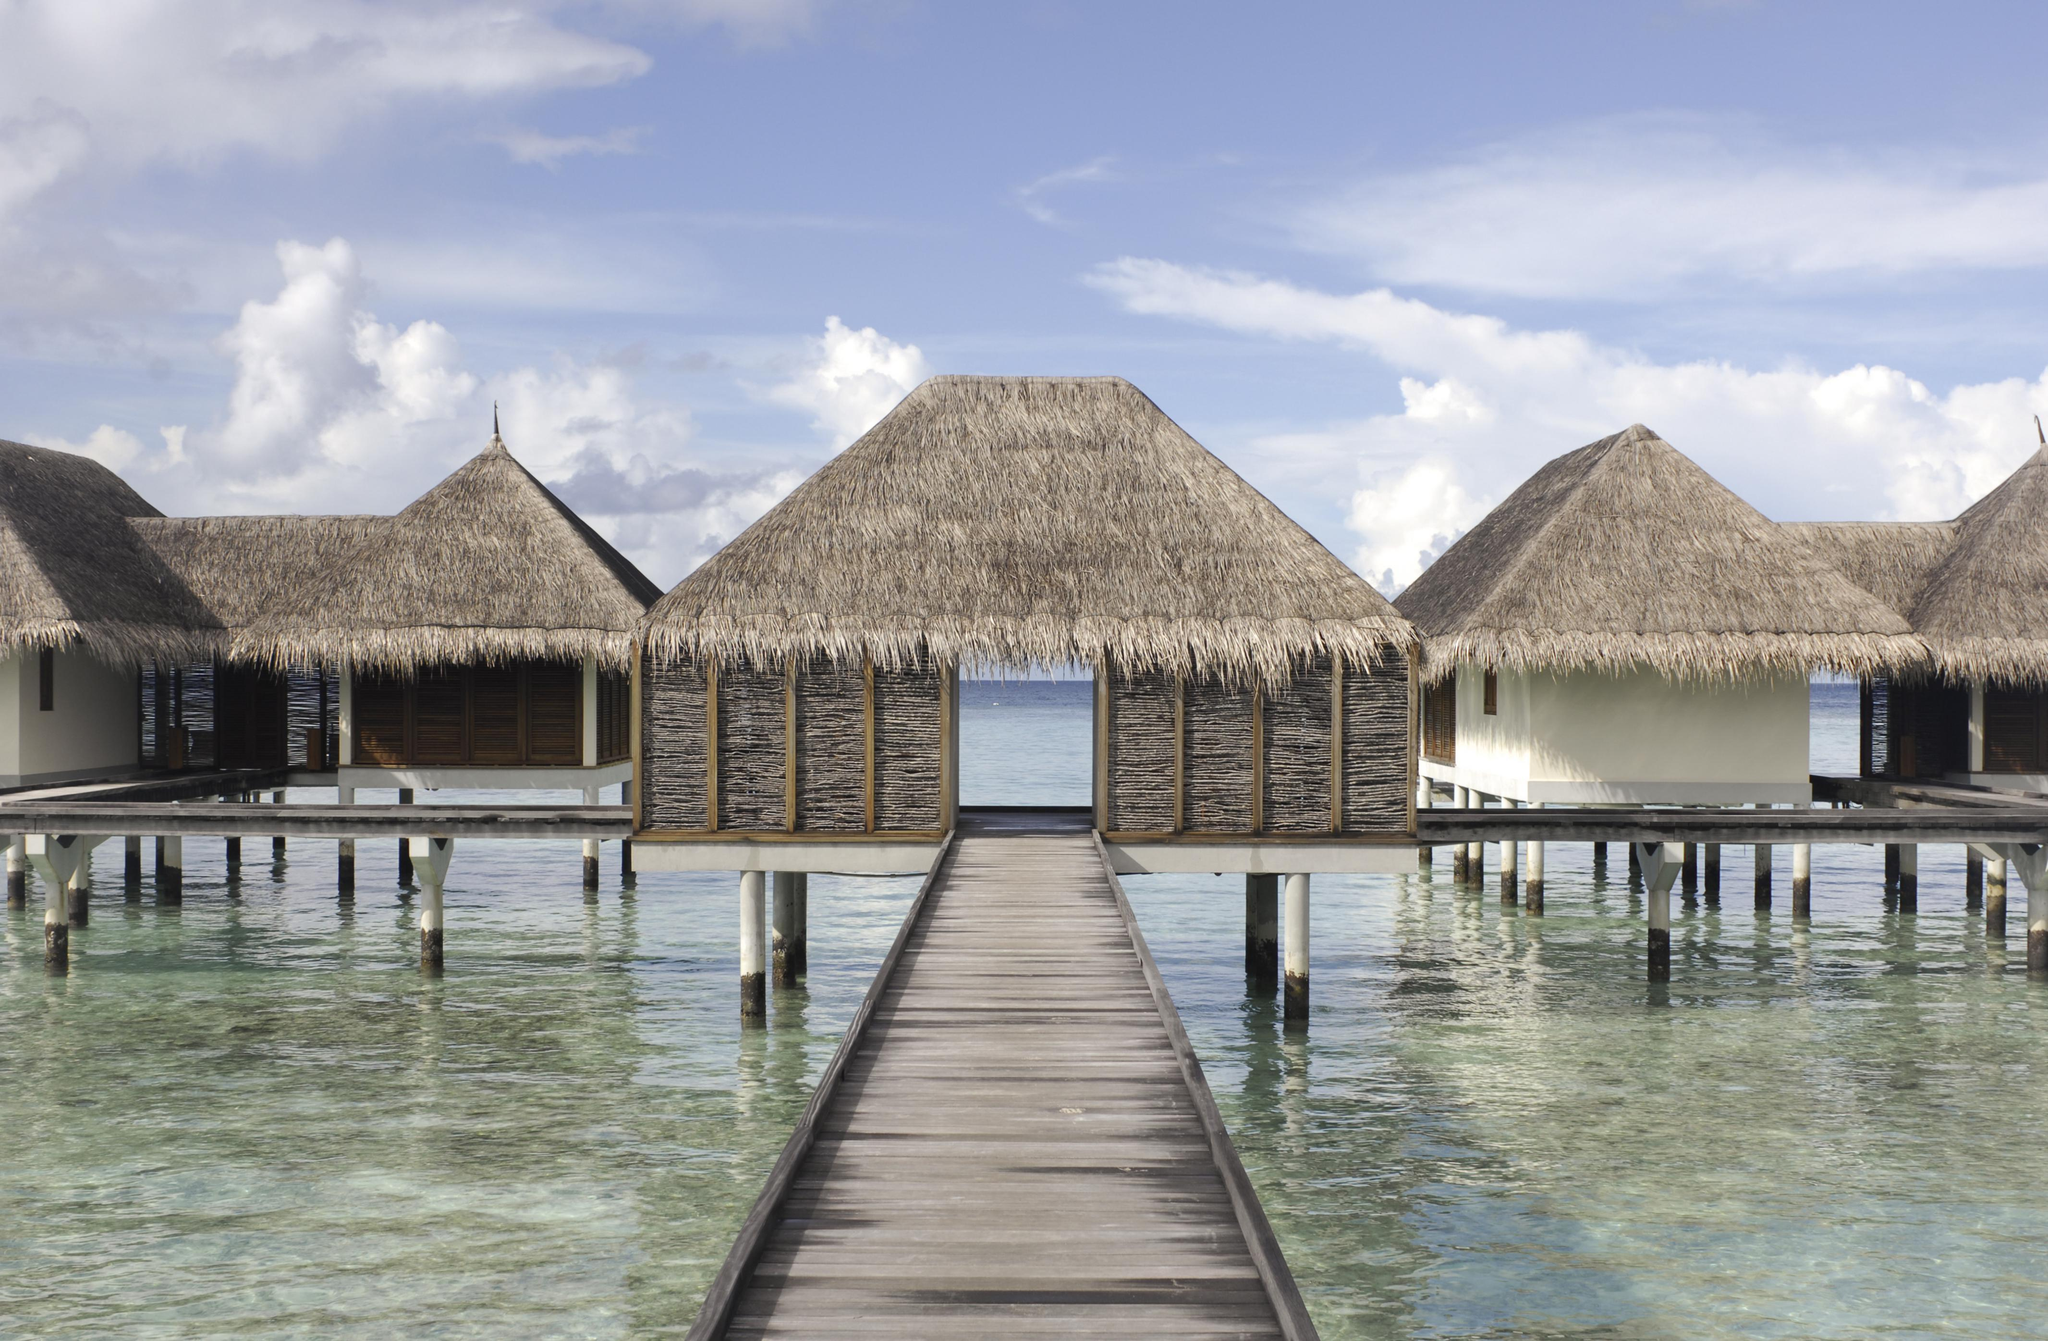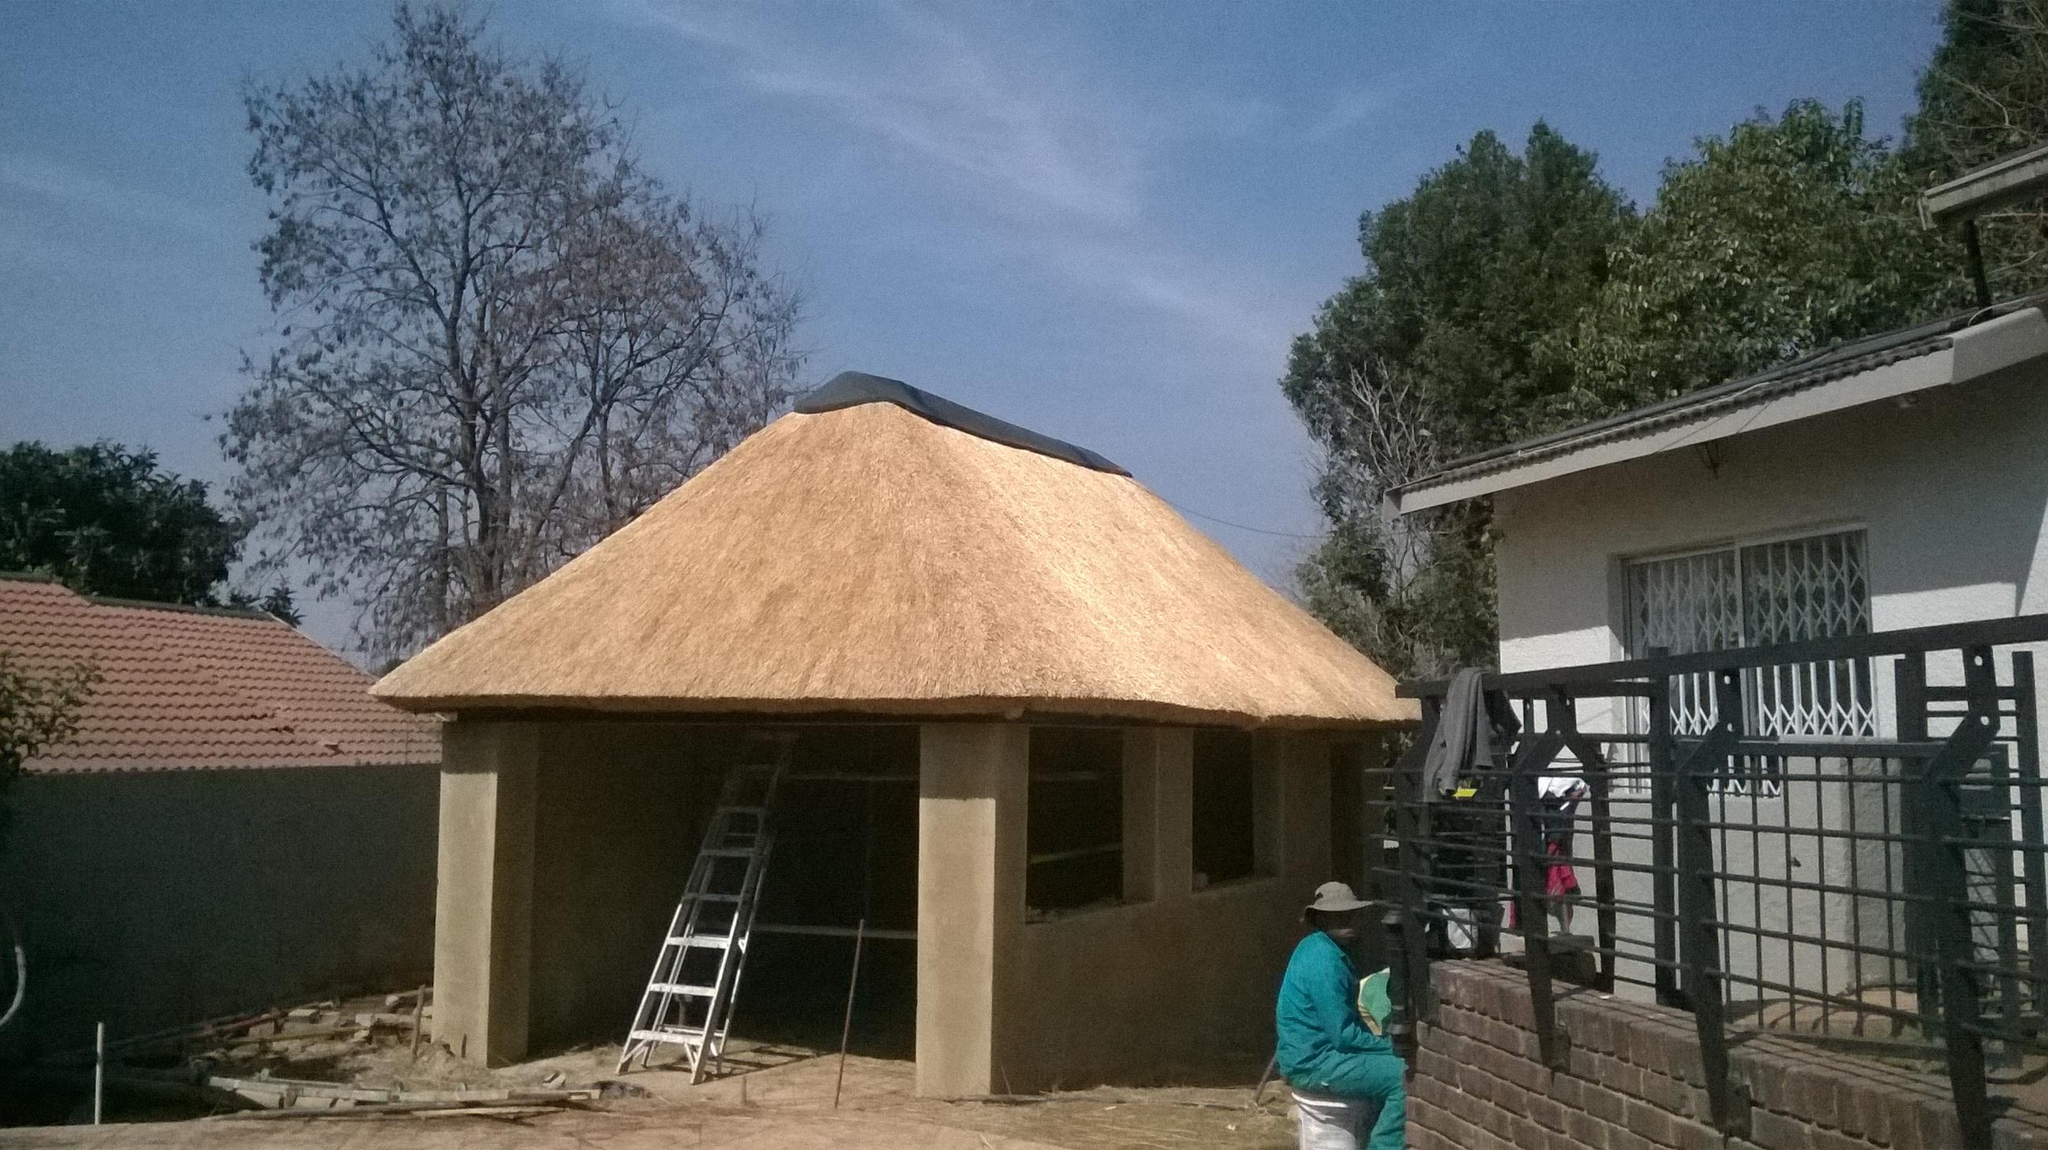The first image is the image on the left, the second image is the image on the right. For the images displayed, is the sentence "The right image shows a long grey building with a peaked roof and an open door, but no windows, and the left image shows a building with a peaked roof and windows on the front." factually correct? Answer yes or no. No. The first image is the image on the left, the second image is the image on the right. Assess this claim about the two images: "The building in the image on the left has a chimney.". Correct or not? Answer yes or no. No. 